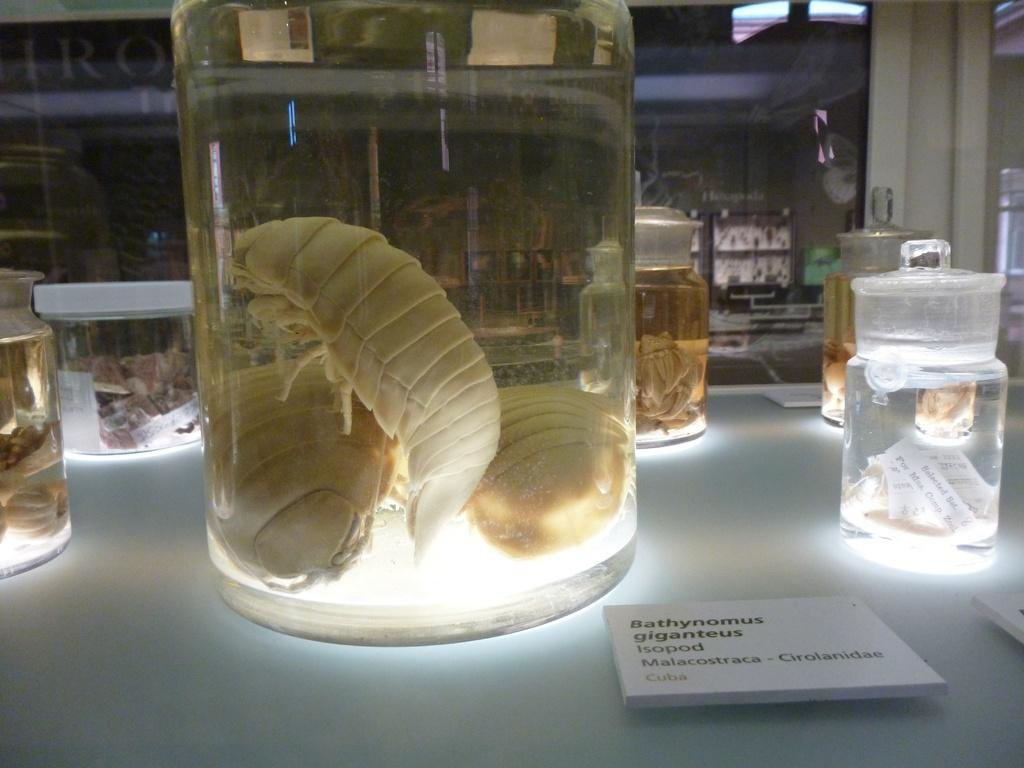<image>
Relay a brief, clear account of the picture shown. a pickled Bathynomus giganteus Isopod Malacostraca from Cuba 